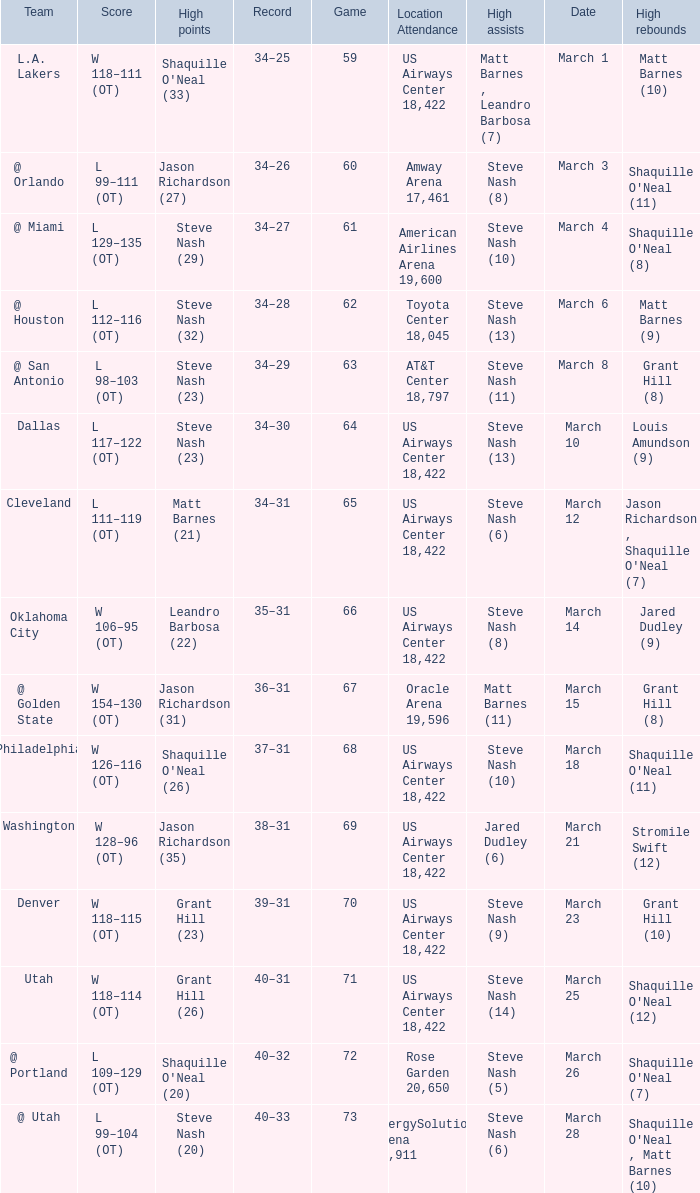After the March 15 game, what was the team's record? 36–31. 